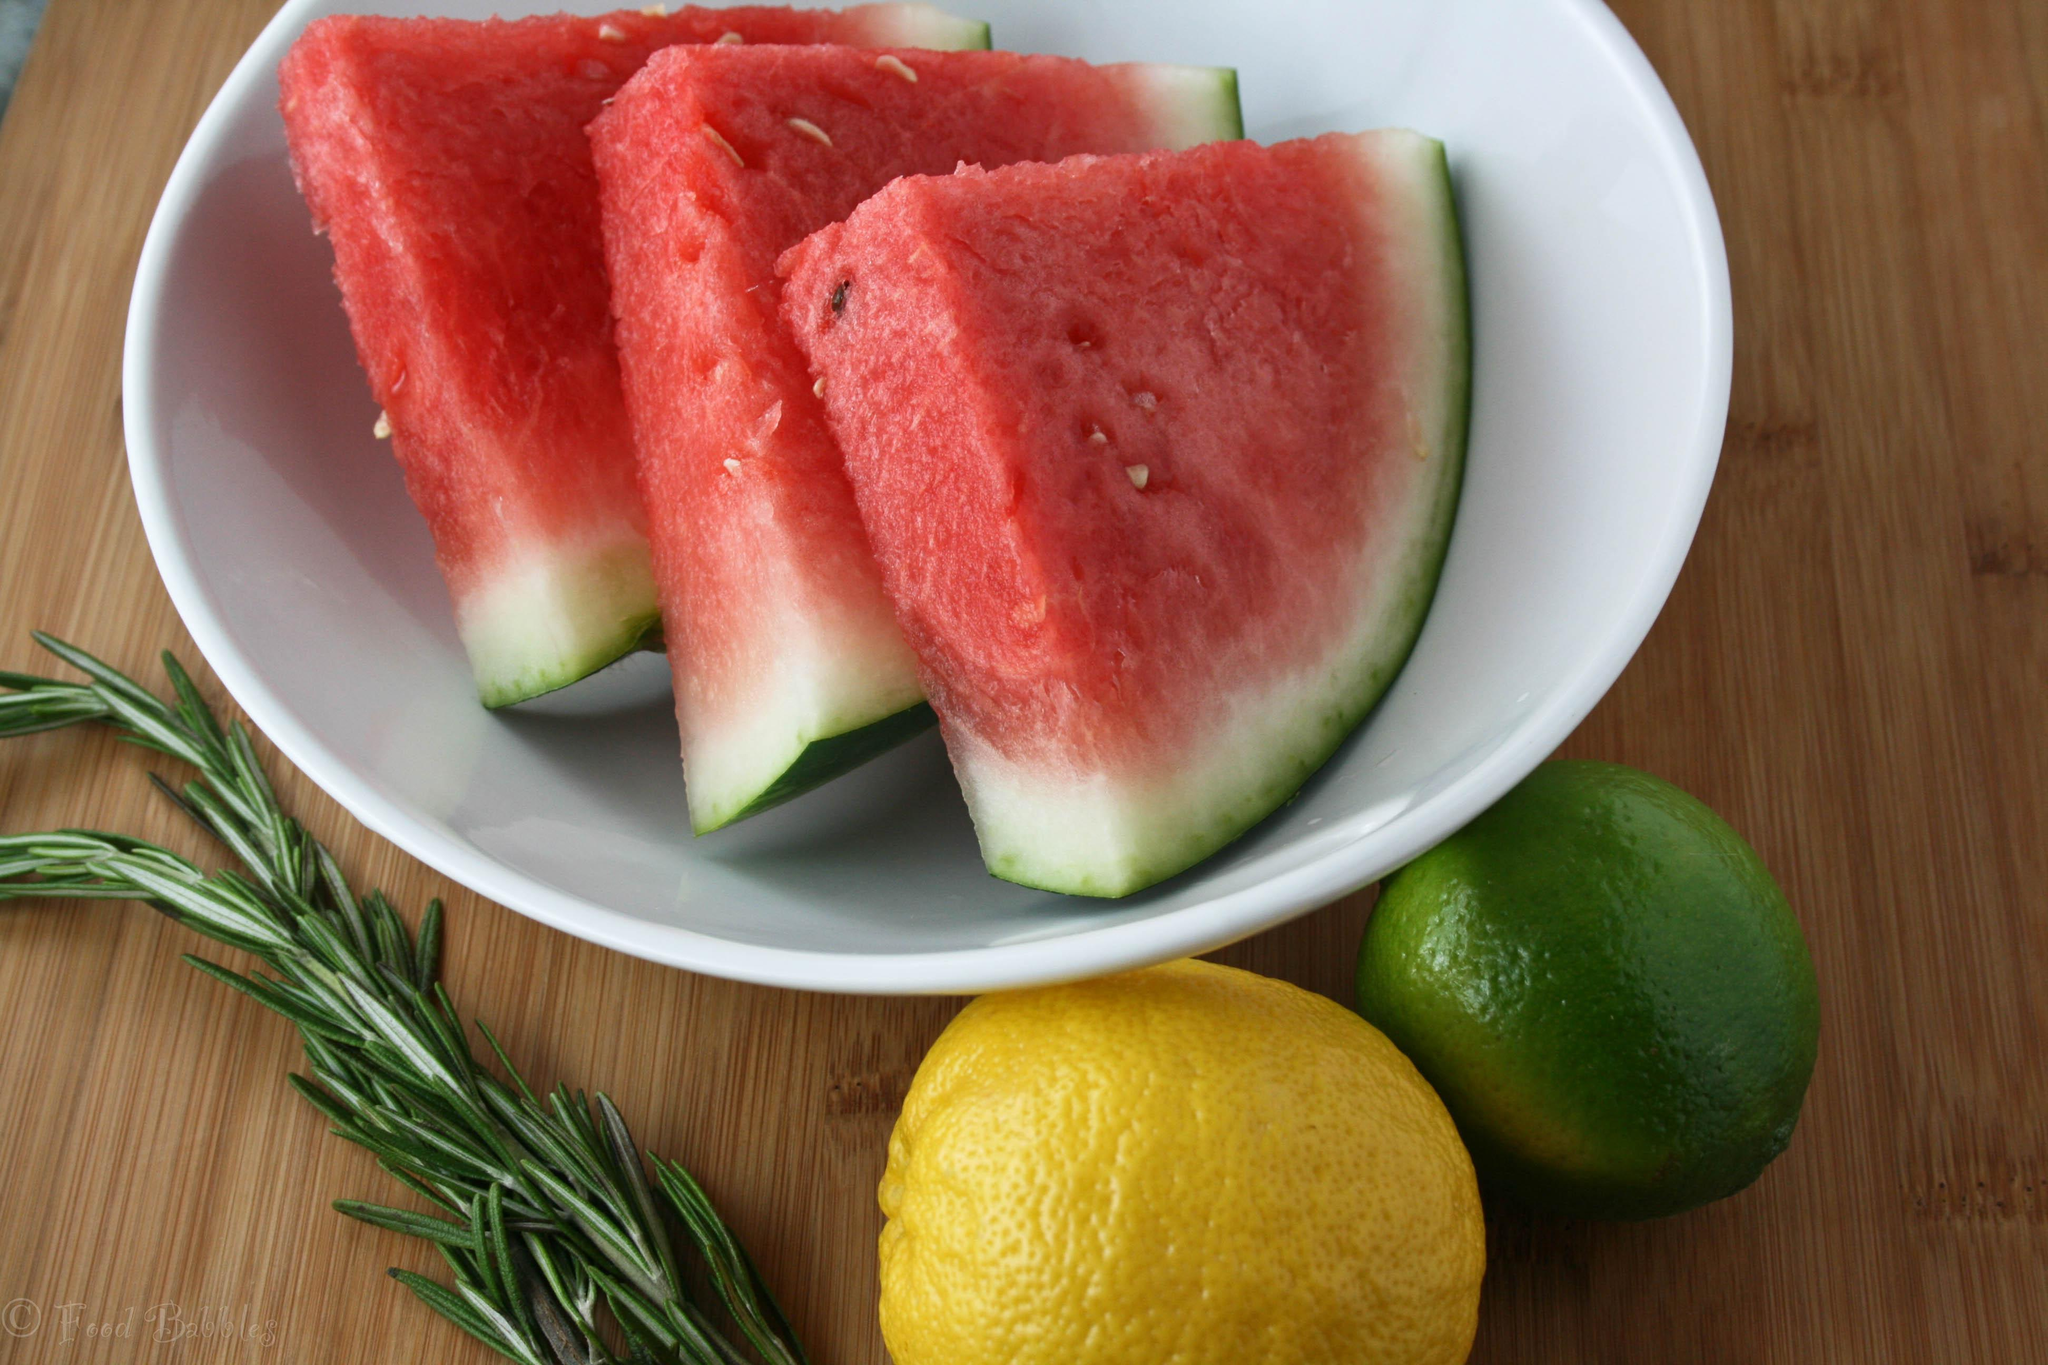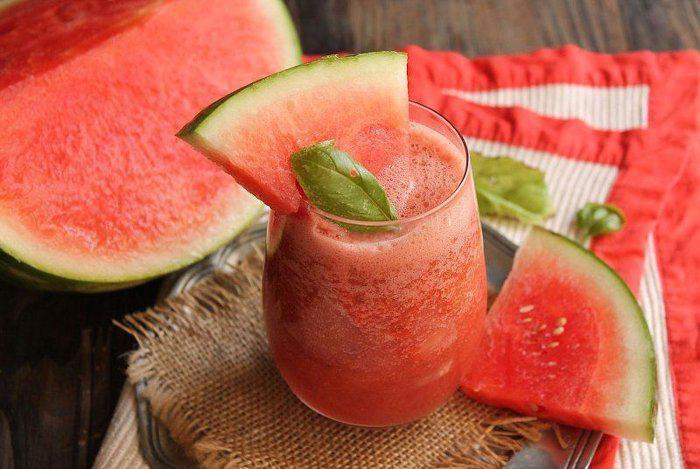The first image is the image on the left, the second image is the image on the right. For the images displayed, is the sentence "There are three whole lemons in one of the images." factually correct? Answer yes or no. No. 